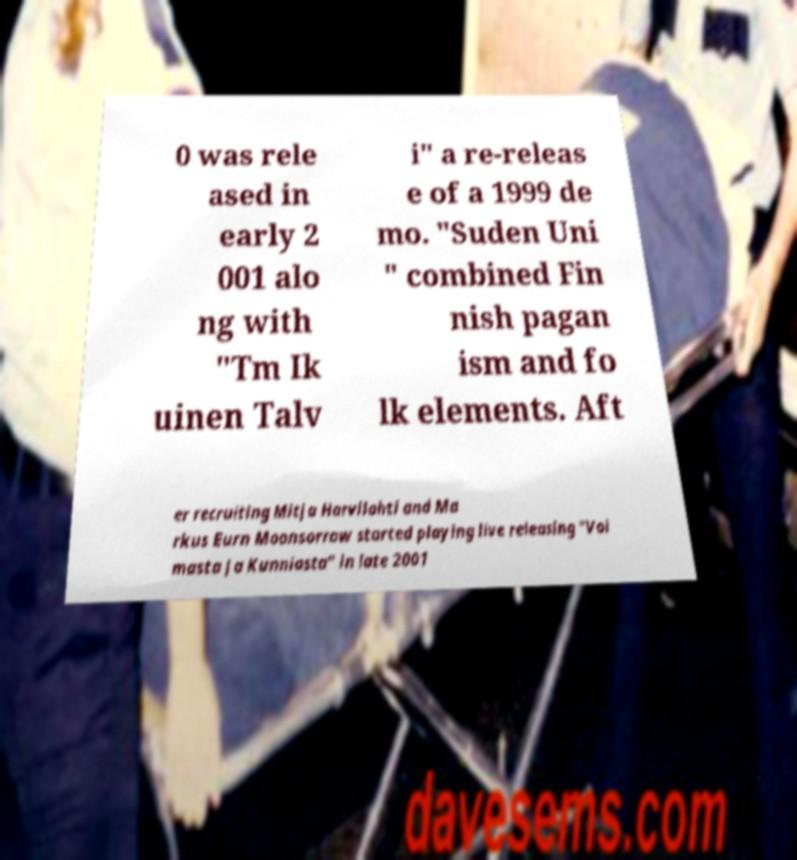There's text embedded in this image that I need extracted. Can you transcribe it verbatim? 0 was rele ased in early 2 001 alo ng with "Tm Ik uinen Talv i" a re-releas e of a 1999 de mo. "Suden Uni " combined Fin nish pagan ism and fo lk elements. Aft er recruiting Mitja Harvilahti and Ma rkus Eurn Moonsorrow started playing live releasing "Voi masta Ja Kunniasta" in late 2001 